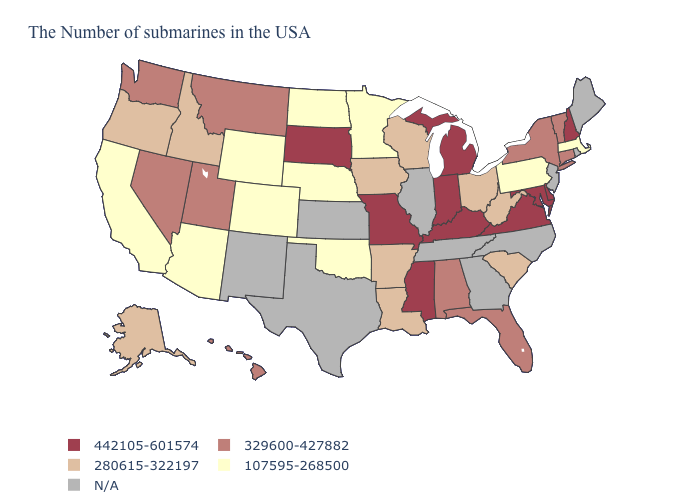Among the states that border Montana , does Wyoming have the lowest value?
Quick response, please. Yes. How many symbols are there in the legend?
Answer briefly. 5. Is the legend a continuous bar?
Quick response, please. No. Among the states that border Nevada , which have the lowest value?
Answer briefly. Arizona, California. Does Minnesota have the lowest value in the MidWest?
Give a very brief answer. Yes. Name the states that have a value in the range 442105-601574?
Short answer required. New Hampshire, Delaware, Maryland, Virginia, Michigan, Kentucky, Indiana, Mississippi, Missouri, South Dakota. Name the states that have a value in the range 329600-427882?
Short answer required. Vermont, Connecticut, New York, Florida, Alabama, Utah, Montana, Nevada, Washington, Hawaii. Name the states that have a value in the range 280615-322197?
Short answer required. South Carolina, West Virginia, Ohio, Wisconsin, Louisiana, Arkansas, Iowa, Idaho, Oregon, Alaska. Does Virginia have the highest value in the South?
Short answer required. Yes. What is the value of Arkansas?
Short answer required. 280615-322197. What is the value of Tennessee?
Answer briefly. N/A. What is the value of Nebraska?
Concise answer only. 107595-268500. Which states have the highest value in the USA?
Quick response, please. New Hampshire, Delaware, Maryland, Virginia, Michigan, Kentucky, Indiana, Mississippi, Missouri, South Dakota. Which states have the lowest value in the MidWest?
Write a very short answer. Minnesota, Nebraska, North Dakota. Name the states that have a value in the range 107595-268500?
Short answer required. Massachusetts, Pennsylvania, Minnesota, Nebraska, Oklahoma, North Dakota, Wyoming, Colorado, Arizona, California. 